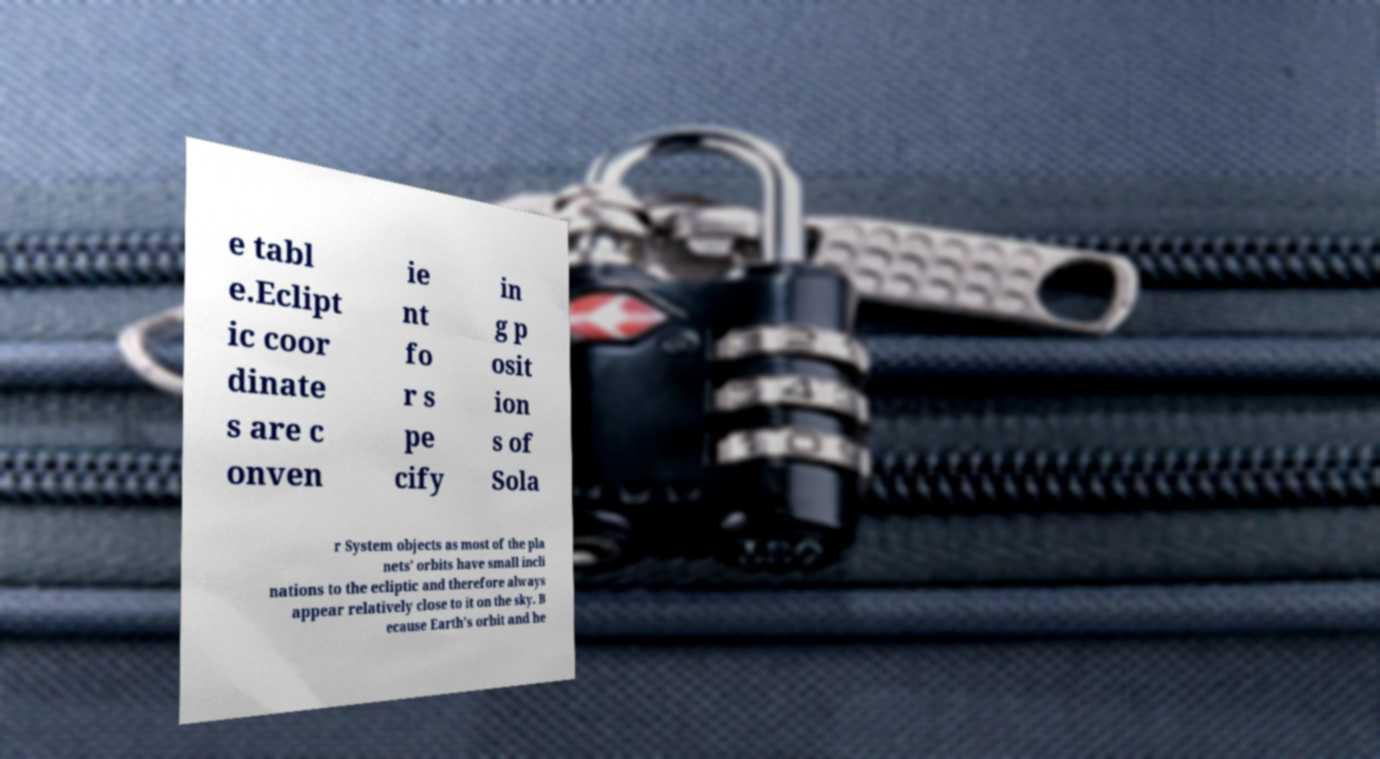For documentation purposes, I need the text within this image transcribed. Could you provide that? e tabl e.Eclipt ic coor dinate s are c onven ie nt fo r s pe cify in g p osit ion s of Sola r System objects as most of the pla nets' orbits have small incli nations to the ecliptic and therefore always appear relatively close to it on the sky. B ecause Earth's orbit and he 